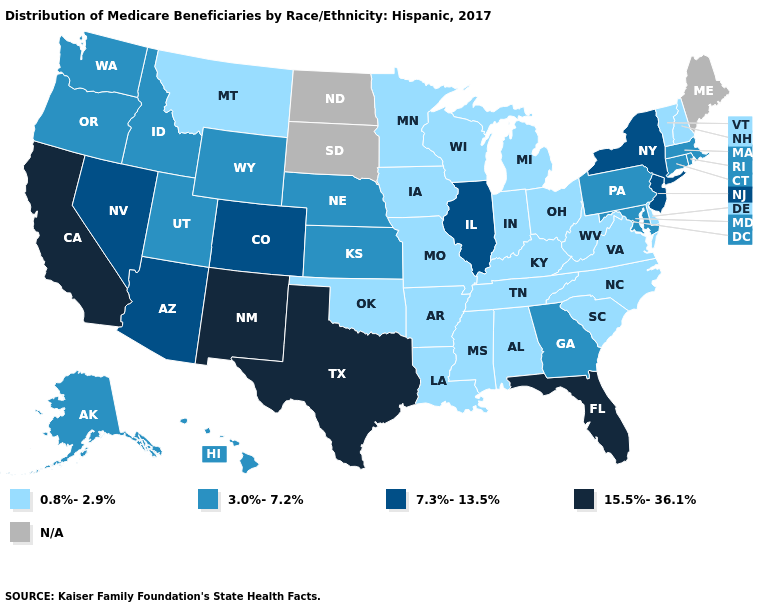What is the value of Rhode Island?
Answer briefly. 3.0%-7.2%. Name the states that have a value in the range 0.8%-2.9%?
Keep it brief. Alabama, Arkansas, Delaware, Indiana, Iowa, Kentucky, Louisiana, Michigan, Minnesota, Mississippi, Missouri, Montana, New Hampshire, North Carolina, Ohio, Oklahoma, South Carolina, Tennessee, Vermont, Virginia, West Virginia, Wisconsin. What is the value of Georgia?
Short answer required. 3.0%-7.2%. What is the lowest value in the MidWest?
Concise answer only. 0.8%-2.9%. What is the value of New Jersey?
Quick response, please. 7.3%-13.5%. Name the states that have a value in the range 3.0%-7.2%?
Be succinct. Alaska, Connecticut, Georgia, Hawaii, Idaho, Kansas, Maryland, Massachusetts, Nebraska, Oregon, Pennsylvania, Rhode Island, Utah, Washington, Wyoming. What is the value of Kansas?
Short answer required. 3.0%-7.2%. What is the lowest value in states that border Maryland?
Quick response, please. 0.8%-2.9%. Name the states that have a value in the range N/A?
Give a very brief answer. Maine, North Dakota, South Dakota. Name the states that have a value in the range 0.8%-2.9%?
Quick response, please. Alabama, Arkansas, Delaware, Indiana, Iowa, Kentucky, Louisiana, Michigan, Minnesota, Mississippi, Missouri, Montana, New Hampshire, North Carolina, Ohio, Oklahoma, South Carolina, Tennessee, Vermont, Virginia, West Virginia, Wisconsin. Which states have the lowest value in the USA?
Short answer required. Alabama, Arkansas, Delaware, Indiana, Iowa, Kentucky, Louisiana, Michigan, Minnesota, Mississippi, Missouri, Montana, New Hampshire, North Carolina, Ohio, Oklahoma, South Carolina, Tennessee, Vermont, Virginia, West Virginia, Wisconsin. Does the map have missing data?
Be succinct. Yes. What is the lowest value in states that border South Carolina?
Be succinct. 0.8%-2.9%. What is the highest value in the USA?
Short answer required. 15.5%-36.1%. 